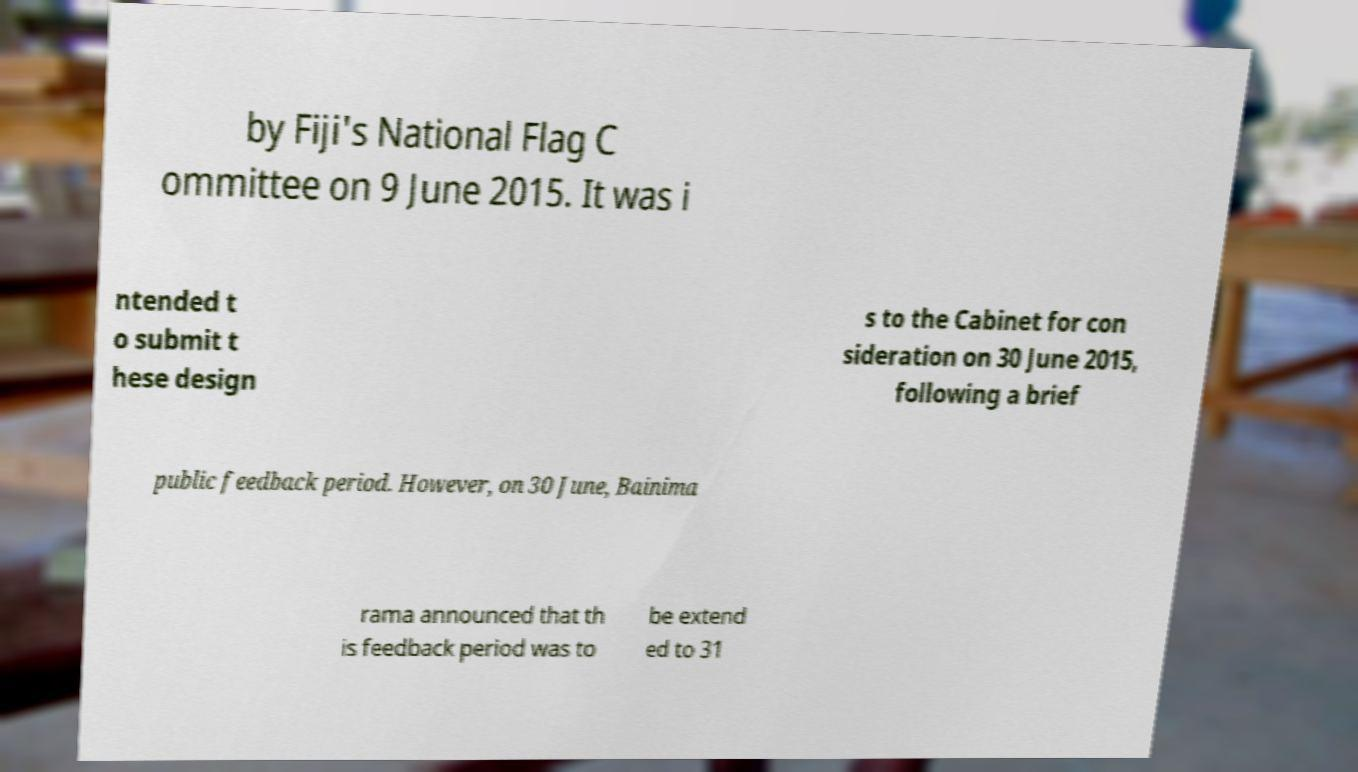Can you accurately transcribe the text from the provided image for me? by Fiji's National Flag C ommittee on 9 June 2015. It was i ntended t o submit t hese design s to the Cabinet for con sideration on 30 June 2015, following a brief public feedback period. However, on 30 June, Bainima rama announced that th is feedback period was to be extend ed to 31 